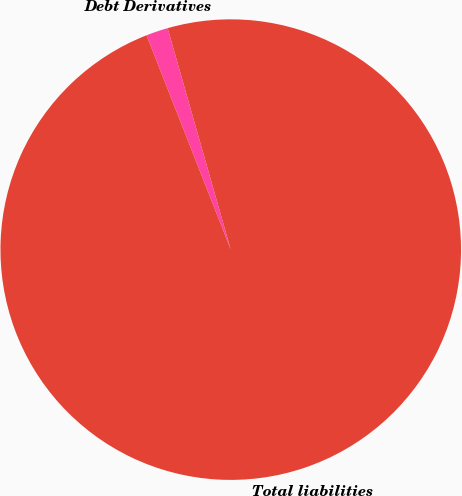<chart> <loc_0><loc_0><loc_500><loc_500><pie_chart><fcel>Debt Derivatives<fcel>Total liabilities<nl><fcel>1.54%<fcel>98.46%<nl></chart> 